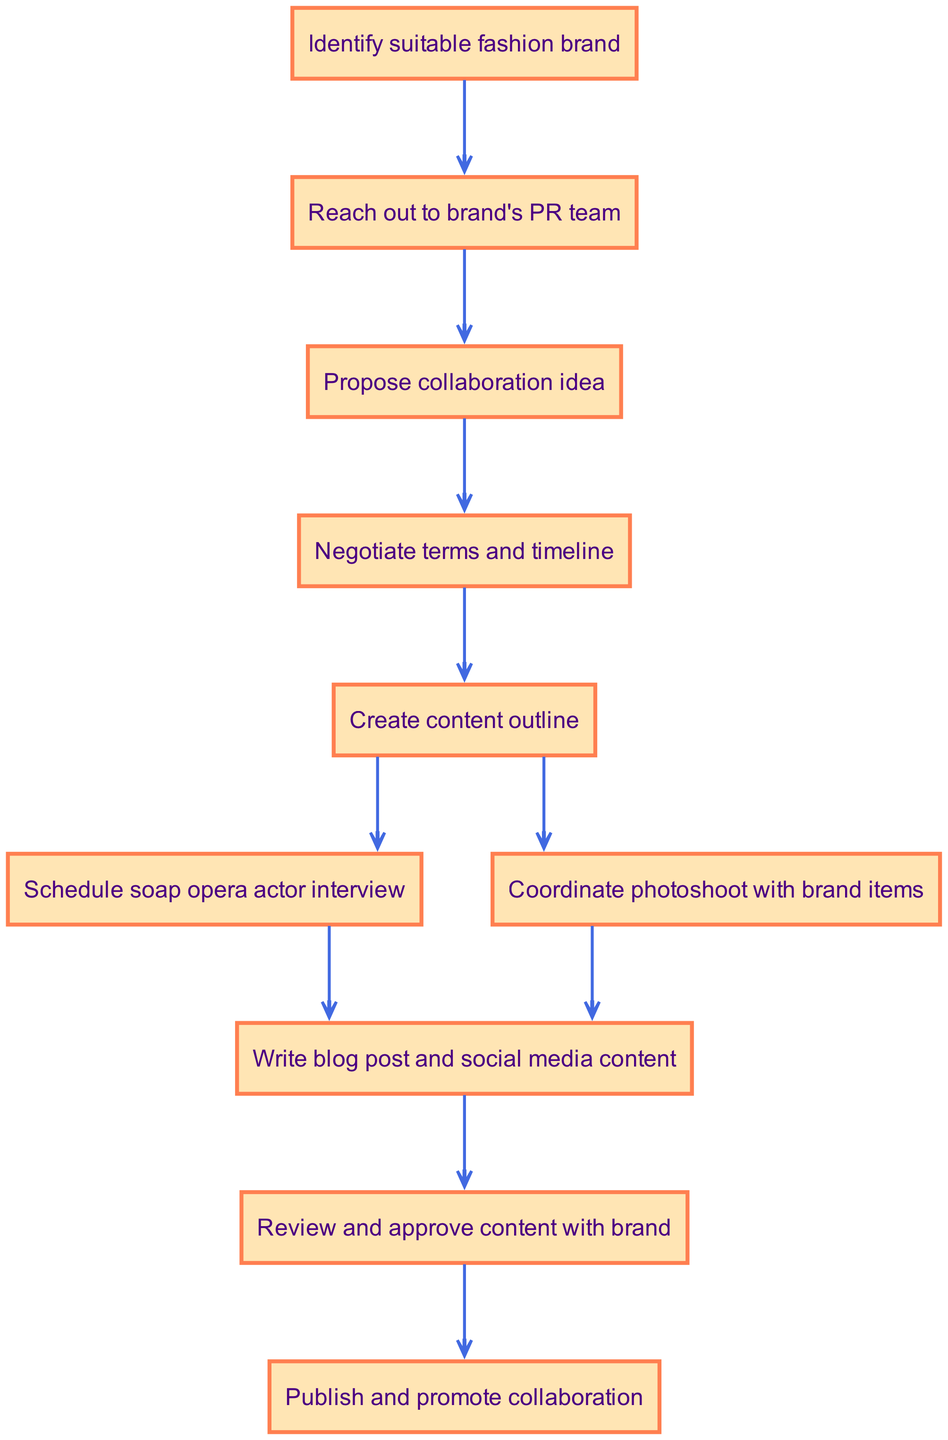What is the first step in the collaboration plan? The first step in the collaboration plan, as shown in the diagram, is to "Identify suitable fashion brand." This is clearly indicated as the starting node in the flowchart.
Answer: Identify suitable fashion brand How many nodes are in the diagram? The diagram has a total of 10 nodes. Each node represents a distinct step in the planning process, and counting them yields this total.
Answer: 10 What follows after proposing the collaboration idea? After "Propose collaboration idea," the next step in the flowchart is "Negotiate terms and timeline." This is indicated by the directed edge leading from the proposal node to the negotiation node.
Answer: Negotiate terms and timeline Which step comes after coordinating the photoshoot with brand items? The step that comes after "Coordinate photoshoot with brand items" is "Write blog post and social media content." This can be traced sequentially from the photoshoot node to the content writing node in the flowchart.
Answer: Write blog post and social media content What is the final step before publishing and promoting the collaboration? The final step before "Publish and promote collaboration" is "Review and approve content with brand." The flowchart depicts this as a direct prerequisite to publishing, highlighting the review process.
Answer: Review and approve content with brand How many edges connect the nodes in the diagram? The diagram contains 9 edges. Each edge represents a directed relationship between two consecutive steps in the planning process, and counting them across the flowchart identifies the total.
Answer: 9 What’s the relationship between creating content outline and scheduling the soap opera actor interview? Both "Create content outline" and "Schedule soap opera actor interview" are subsequent steps following the negotiation of terms. They are connected to the same previous node, indicating they can occur in parallel after the negotiation stage.
Answer: Parallel steps Is it necessary to reach out to the brand's PR team? Yes, it is necessary to reach out to the brand's PR team. This step is critical as it establishes communication and initiates the collaboration process following the identification of a suitable fashion brand.
Answer: Yes Which step precedes the writing of blog posts and social media content? The step that precedes "Write blog post and social media content" is "Schedule soap opera actor interview" and "Coordinate photoshoot with brand items." Both are prerequisites that must be completed prior to writing content.
Answer: Schedule soap opera actor interview and Coordinate photoshoot with brand items 